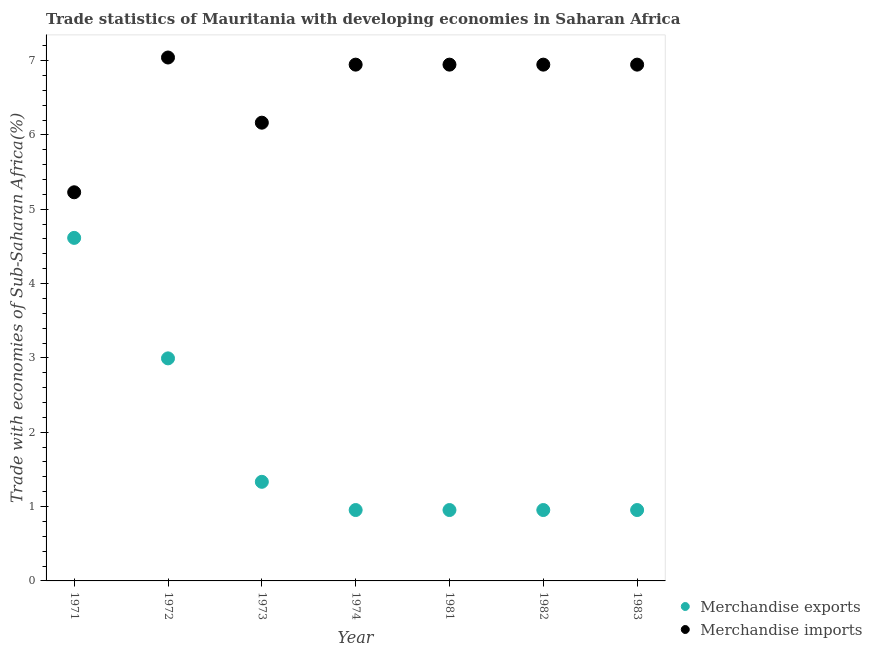Is the number of dotlines equal to the number of legend labels?
Your response must be concise. Yes. What is the merchandise imports in 1971?
Provide a short and direct response. 5.23. Across all years, what is the maximum merchandise imports?
Keep it short and to the point. 7.04. Across all years, what is the minimum merchandise exports?
Make the answer very short. 0.95. In which year was the merchandise exports maximum?
Give a very brief answer. 1971. In which year was the merchandise exports minimum?
Your answer should be very brief. 1981. What is the total merchandise imports in the graph?
Give a very brief answer. 46.21. What is the difference between the merchandise exports in 1972 and that in 1974?
Keep it short and to the point. 2.04. What is the difference between the merchandise exports in 1981 and the merchandise imports in 1973?
Offer a very short reply. -5.21. What is the average merchandise exports per year?
Your answer should be very brief. 1.82. In the year 1973, what is the difference between the merchandise exports and merchandise imports?
Your answer should be compact. -4.83. In how many years, is the merchandise imports greater than 2 %?
Your response must be concise. 7. What is the ratio of the merchandise imports in 1982 to that in 1983?
Keep it short and to the point. 1. Is the difference between the merchandise imports in 1974 and 1982 greater than the difference between the merchandise exports in 1974 and 1982?
Offer a terse response. Yes. What is the difference between the highest and the second highest merchandise imports?
Your response must be concise. 0.1. What is the difference between the highest and the lowest merchandise imports?
Your response must be concise. 1.81. In how many years, is the merchandise imports greater than the average merchandise imports taken over all years?
Offer a terse response. 5. Does the merchandise exports monotonically increase over the years?
Keep it short and to the point. No. How many dotlines are there?
Your answer should be very brief. 2. How many years are there in the graph?
Give a very brief answer. 7. Are the values on the major ticks of Y-axis written in scientific E-notation?
Offer a terse response. No. What is the title of the graph?
Offer a terse response. Trade statistics of Mauritania with developing economies in Saharan Africa. What is the label or title of the Y-axis?
Offer a very short reply. Trade with economies of Sub-Saharan Africa(%). What is the Trade with economies of Sub-Saharan Africa(%) of Merchandise exports in 1971?
Your answer should be compact. 4.61. What is the Trade with economies of Sub-Saharan Africa(%) in Merchandise imports in 1971?
Your response must be concise. 5.23. What is the Trade with economies of Sub-Saharan Africa(%) in Merchandise exports in 1972?
Make the answer very short. 2.99. What is the Trade with economies of Sub-Saharan Africa(%) in Merchandise imports in 1972?
Give a very brief answer. 7.04. What is the Trade with economies of Sub-Saharan Africa(%) in Merchandise exports in 1973?
Offer a terse response. 1.33. What is the Trade with economies of Sub-Saharan Africa(%) of Merchandise imports in 1973?
Your answer should be very brief. 6.16. What is the Trade with economies of Sub-Saharan Africa(%) in Merchandise exports in 1974?
Ensure brevity in your answer.  0.95. What is the Trade with economies of Sub-Saharan Africa(%) in Merchandise imports in 1974?
Offer a terse response. 6.94. What is the Trade with economies of Sub-Saharan Africa(%) of Merchandise exports in 1981?
Offer a terse response. 0.95. What is the Trade with economies of Sub-Saharan Africa(%) of Merchandise imports in 1981?
Keep it short and to the point. 6.94. What is the Trade with economies of Sub-Saharan Africa(%) of Merchandise exports in 1982?
Ensure brevity in your answer.  0.95. What is the Trade with economies of Sub-Saharan Africa(%) in Merchandise imports in 1982?
Provide a short and direct response. 6.94. What is the Trade with economies of Sub-Saharan Africa(%) of Merchandise exports in 1983?
Offer a terse response. 0.95. What is the Trade with economies of Sub-Saharan Africa(%) of Merchandise imports in 1983?
Provide a succinct answer. 6.94. Across all years, what is the maximum Trade with economies of Sub-Saharan Africa(%) of Merchandise exports?
Give a very brief answer. 4.61. Across all years, what is the maximum Trade with economies of Sub-Saharan Africa(%) in Merchandise imports?
Provide a succinct answer. 7.04. Across all years, what is the minimum Trade with economies of Sub-Saharan Africa(%) of Merchandise exports?
Offer a very short reply. 0.95. Across all years, what is the minimum Trade with economies of Sub-Saharan Africa(%) in Merchandise imports?
Give a very brief answer. 5.23. What is the total Trade with economies of Sub-Saharan Africa(%) in Merchandise exports in the graph?
Your response must be concise. 12.76. What is the total Trade with economies of Sub-Saharan Africa(%) in Merchandise imports in the graph?
Make the answer very short. 46.21. What is the difference between the Trade with economies of Sub-Saharan Africa(%) in Merchandise exports in 1971 and that in 1972?
Ensure brevity in your answer.  1.62. What is the difference between the Trade with economies of Sub-Saharan Africa(%) of Merchandise imports in 1971 and that in 1972?
Provide a succinct answer. -1.81. What is the difference between the Trade with economies of Sub-Saharan Africa(%) in Merchandise exports in 1971 and that in 1973?
Your answer should be compact. 3.28. What is the difference between the Trade with economies of Sub-Saharan Africa(%) in Merchandise imports in 1971 and that in 1973?
Your answer should be very brief. -0.94. What is the difference between the Trade with economies of Sub-Saharan Africa(%) of Merchandise exports in 1971 and that in 1974?
Give a very brief answer. 3.66. What is the difference between the Trade with economies of Sub-Saharan Africa(%) of Merchandise imports in 1971 and that in 1974?
Provide a succinct answer. -1.72. What is the difference between the Trade with economies of Sub-Saharan Africa(%) of Merchandise exports in 1971 and that in 1981?
Give a very brief answer. 3.66. What is the difference between the Trade with economies of Sub-Saharan Africa(%) in Merchandise imports in 1971 and that in 1981?
Ensure brevity in your answer.  -1.72. What is the difference between the Trade with economies of Sub-Saharan Africa(%) in Merchandise exports in 1971 and that in 1982?
Provide a short and direct response. 3.66. What is the difference between the Trade with economies of Sub-Saharan Africa(%) in Merchandise imports in 1971 and that in 1982?
Provide a succinct answer. -1.72. What is the difference between the Trade with economies of Sub-Saharan Africa(%) of Merchandise exports in 1971 and that in 1983?
Give a very brief answer. 3.66. What is the difference between the Trade with economies of Sub-Saharan Africa(%) of Merchandise imports in 1971 and that in 1983?
Your answer should be compact. -1.72. What is the difference between the Trade with economies of Sub-Saharan Africa(%) in Merchandise exports in 1972 and that in 1973?
Your answer should be very brief. 1.66. What is the difference between the Trade with economies of Sub-Saharan Africa(%) in Merchandise imports in 1972 and that in 1973?
Make the answer very short. 0.88. What is the difference between the Trade with economies of Sub-Saharan Africa(%) in Merchandise exports in 1972 and that in 1974?
Ensure brevity in your answer.  2.04. What is the difference between the Trade with economies of Sub-Saharan Africa(%) in Merchandise imports in 1972 and that in 1974?
Provide a succinct answer. 0.1. What is the difference between the Trade with economies of Sub-Saharan Africa(%) in Merchandise exports in 1972 and that in 1981?
Your answer should be compact. 2.04. What is the difference between the Trade with economies of Sub-Saharan Africa(%) in Merchandise imports in 1972 and that in 1981?
Keep it short and to the point. 0.1. What is the difference between the Trade with economies of Sub-Saharan Africa(%) in Merchandise exports in 1972 and that in 1982?
Make the answer very short. 2.04. What is the difference between the Trade with economies of Sub-Saharan Africa(%) of Merchandise imports in 1972 and that in 1982?
Provide a short and direct response. 0.1. What is the difference between the Trade with economies of Sub-Saharan Africa(%) of Merchandise exports in 1972 and that in 1983?
Your response must be concise. 2.04. What is the difference between the Trade with economies of Sub-Saharan Africa(%) of Merchandise imports in 1972 and that in 1983?
Provide a succinct answer. 0.1. What is the difference between the Trade with economies of Sub-Saharan Africa(%) of Merchandise exports in 1973 and that in 1974?
Offer a very short reply. 0.38. What is the difference between the Trade with economies of Sub-Saharan Africa(%) of Merchandise imports in 1973 and that in 1974?
Offer a terse response. -0.78. What is the difference between the Trade with economies of Sub-Saharan Africa(%) of Merchandise exports in 1973 and that in 1981?
Your answer should be compact. 0.38. What is the difference between the Trade with economies of Sub-Saharan Africa(%) in Merchandise imports in 1973 and that in 1981?
Provide a short and direct response. -0.78. What is the difference between the Trade with economies of Sub-Saharan Africa(%) of Merchandise exports in 1973 and that in 1982?
Offer a terse response. 0.38. What is the difference between the Trade with economies of Sub-Saharan Africa(%) of Merchandise imports in 1973 and that in 1982?
Offer a very short reply. -0.78. What is the difference between the Trade with economies of Sub-Saharan Africa(%) of Merchandise exports in 1973 and that in 1983?
Keep it short and to the point. 0.38. What is the difference between the Trade with economies of Sub-Saharan Africa(%) in Merchandise imports in 1973 and that in 1983?
Provide a succinct answer. -0.78. What is the difference between the Trade with economies of Sub-Saharan Africa(%) of Merchandise imports in 1974 and that in 1981?
Provide a short and direct response. -0. What is the difference between the Trade with economies of Sub-Saharan Africa(%) in Merchandise exports in 1974 and that in 1982?
Provide a short and direct response. -0. What is the difference between the Trade with economies of Sub-Saharan Africa(%) in Merchandise exports in 1974 and that in 1983?
Your response must be concise. -0. What is the difference between the Trade with economies of Sub-Saharan Africa(%) of Merchandise imports in 1974 and that in 1983?
Your answer should be very brief. -0. What is the difference between the Trade with economies of Sub-Saharan Africa(%) of Merchandise exports in 1981 and that in 1983?
Give a very brief answer. -0. What is the difference between the Trade with economies of Sub-Saharan Africa(%) in Merchandise imports in 1982 and that in 1983?
Make the answer very short. -0. What is the difference between the Trade with economies of Sub-Saharan Africa(%) in Merchandise exports in 1971 and the Trade with economies of Sub-Saharan Africa(%) in Merchandise imports in 1972?
Your response must be concise. -2.43. What is the difference between the Trade with economies of Sub-Saharan Africa(%) in Merchandise exports in 1971 and the Trade with economies of Sub-Saharan Africa(%) in Merchandise imports in 1973?
Keep it short and to the point. -1.55. What is the difference between the Trade with economies of Sub-Saharan Africa(%) in Merchandise exports in 1971 and the Trade with economies of Sub-Saharan Africa(%) in Merchandise imports in 1974?
Your response must be concise. -2.33. What is the difference between the Trade with economies of Sub-Saharan Africa(%) in Merchandise exports in 1971 and the Trade with economies of Sub-Saharan Africa(%) in Merchandise imports in 1981?
Offer a very short reply. -2.33. What is the difference between the Trade with economies of Sub-Saharan Africa(%) of Merchandise exports in 1971 and the Trade with economies of Sub-Saharan Africa(%) of Merchandise imports in 1982?
Ensure brevity in your answer.  -2.33. What is the difference between the Trade with economies of Sub-Saharan Africa(%) of Merchandise exports in 1971 and the Trade with economies of Sub-Saharan Africa(%) of Merchandise imports in 1983?
Give a very brief answer. -2.33. What is the difference between the Trade with economies of Sub-Saharan Africa(%) of Merchandise exports in 1972 and the Trade with economies of Sub-Saharan Africa(%) of Merchandise imports in 1973?
Ensure brevity in your answer.  -3.17. What is the difference between the Trade with economies of Sub-Saharan Africa(%) in Merchandise exports in 1972 and the Trade with economies of Sub-Saharan Africa(%) in Merchandise imports in 1974?
Give a very brief answer. -3.95. What is the difference between the Trade with economies of Sub-Saharan Africa(%) of Merchandise exports in 1972 and the Trade with economies of Sub-Saharan Africa(%) of Merchandise imports in 1981?
Give a very brief answer. -3.95. What is the difference between the Trade with economies of Sub-Saharan Africa(%) in Merchandise exports in 1972 and the Trade with economies of Sub-Saharan Africa(%) in Merchandise imports in 1982?
Provide a short and direct response. -3.95. What is the difference between the Trade with economies of Sub-Saharan Africa(%) of Merchandise exports in 1972 and the Trade with economies of Sub-Saharan Africa(%) of Merchandise imports in 1983?
Provide a short and direct response. -3.95. What is the difference between the Trade with economies of Sub-Saharan Africa(%) of Merchandise exports in 1973 and the Trade with economies of Sub-Saharan Africa(%) of Merchandise imports in 1974?
Your answer should be very brief. -5.61. What is the difference between the Trade with economies of Sub-Saharan Africa(%) in Merchandise exports in 1973 and the Trade with economies of Sub-Saharan Africa(%) in Merchandise imports in 1981?
Provide a short and direct response. -5.61. What is the difference between the Trade with economies of Sub-Saharan Africa(%) in Merchandise exports in 1973 and the Trade with economies of Sub-Saharan Africa(%) in Merchandise imports in 1982?
Offer a very short reply. -5.61. What is the difference between the Trade with economies of Sub-Saharan Africa(%) of Merchandise exports in 1973 and the Trade with economies of Sub-Saharan Africa(%) of Merchandise imports in 1983?
Give a very brief answer. -5.61. What is the difference between the Trade with economies of Sub-Saharan Africa(%) of Merchandise exports in 1974 and the Trade with economies of Sub-Saharan Africa(%) of Merchandise imports in 1981?
Your answer should be compact. -5.99. What is the difference between the Trade with economies of Sub-Saharan Africa(%) in Merchandise exports in 1974 and the Trade with economies of Sub-Saharan Africa(%) in Merchandise imports in 1982?
Your answer should be very brief. -5.99. What is the difference between the Trade with economies of Sub-Saharan Africa(%) in Merchandise exports in 1974 and the Trade with economies of Sub-Saharan Africa(%) in Merchandise imports in 1983?
Offer a terse response. -5.99. What is the difference between the Trade with economies of Sub-Saharan Africa(%) in Merchandise exports in 1981 and the Trade with economies of Sub-Saharan Africa(%) in Merchandise imports in 1982?
Offer a terse response. -5.99. What is the difference between the Trade with economies of Sub-Saharan Africa(%) of Merchandise exports in 1981 and the Trade with economies of Sub-Saharan Africa(%) of Merchandise imports in 1983?
Your response must be concise. -5.99. What is the difference between the Trade with economies of Sub-Saharan Africa(%) of Merchandise exports in 1982 and the Trade with economies of Sub-Saharan Africa(%) of Merchandise imports in 1983?
Your response must be concise. -5.99. What is the average Trade with economies of Sub-Saharan Africa(%) of Merchandise exports per year?
Your answer should be very brief. 1.82. What is the average Trade with economies of Sub-Saharan Africa(%) of Merchandise imports per year?
Your answer should be very brief. 6.6. In the year 1971, what is the difference between the Trade with economies of Sub-Saharan Africa(%) of Merchandise exports and Trade with economies of Sub-Saharan Africa(%) of Merchandise imports?
Give a very brief answer. -0.61. In the year 1972, what is the difference between the Trade with economies of Sub-Saharan Africa(%) of Merchandise exports and Trade with economies of Sub-Saharan Africa(%) of Merchandise imports?
Offer a terse response. -4.05. In the year 1973, what is the difference between the Trade with economies of Sub-Saharan Africa(%) in Merchandise exports and Trade with economies of Sub-Saharan Africa(%) in Merchandise imports?
Keep it short and to the point. -4.83. In the year 1974, what is the difference between the Trade with economies of Sub-Saharan Africa(%) in Merchandise exports and Trade with economies of Sub-Saharan Africa(%) in Merchandise imports?
Make the answer very short. -5.99. In the year 1981, what is the difference between the Trade with economies of Sub-Saharan Africa(%) in Merchandise exports and Trade with economies of Sub-Saharan Africa(%) in Merchandise imports?
Offer a very short reply. -5.99. In the year 1982, what is the difference between the Trade with economies of Sub-Saharan Africa(%) of Merchandise exports and Trade with economies of Sub-Saharan Africa(%) of Merchandise imports?
Keep it short and to the point. -5.99. In the year 1983, what is the difference between the Trade with economies of Sub-Saharan Africa(%) of Merchandise exports and Trade with economies of Sub-Saharan Africa(%) of Merchandise imports?
Offer a very short reply. -5.99. What is the ratio of the Trade with economies of Sub-Saharan Africa(%) of Merchandise exports in 1971 to that in 1972?
Offer a very short reply. 1.54. What is the ratio of the Trade with economies of Sub-Saharan Africa(%) of Merchandise imports in 1971 to that in 1972?
Your answer should be very brief. 0.74. What is the ratio of the Trade with economies of Sub-Saharan Africa(%) in Merchandise exports in 1971 to that in 1973?
Make the answer very short. 3.46. What is the ratio of the Trade with economies of Sub-Saharan Africa(%) in Merchandise imports in 1971 to that in 1973?
Your answer should be compact. 0.85. What is the ratio of the Trade with economies of Sub-Saharan Africa(%) in Merchandise exports in 1971 to that in 1974?
Your answer should be very brief. 4.84. What is the ratio of the Trade with economies of Sub-Saharan Africa(%) in Merchandise imports in 1971 to that in 1974?
Offer a very short reply. 0.75. What is the ratio of the Trade with economies of Sub-Saharan Africa(%) of Merchandise exports in 1971 to that in 1981?
Ensure brevity in your answer.  4.84. What is the ratio of the Trade with economies of Sub-Saharan Africa(%) of Merchandise imports in 1971 to that in 1981?
Keep it short and to the point. 0.75. What is the ratio of the Trade with economies of Sub-Saharan Africa(%) in Merchandise exports in 1971 to that in 1982?
Keep it short and to the point. 4.84. What is the ratio of the Trade with economies of Sub-Saharan Africa(%) in Merchandise imports in 1971 to that in 1982?
Give a very brief answer. 0.75. What is the ratio of the Trade with economies of Sub-Saharan Africa(%) of Merchandise exports in 1971 to that in 1983?
Your response must be concise. 4.84. What is the ratio of the Trade with economies of Sub-Saharan Africa(%) of Merchandise imports in 1971 to that in 1983?
Your answer should be very brief. 0.75. What is the ratio of the Trade with economies of Sub-Saharan Africa(%) in Merchandise exports in 1972 to that in 1973?
Keep it short and to the point. 2.25. What is the ratio of the Trade with economies of Sub-Saharan Africa(%) of Merchandise imports in 1972 to that in 1973?
Keep it short and to the point. 1.14. What is the ratio of the Trade with economies of Sub-Saharan Africa(%) in Merchandise exports in 1972 to that in 1974?
Give a very brief answer. 3.14. What is the ratio of the Trade with economies of Sub-Saharan Africa(%) of Merchandise imports in 1972 to that in 1974?
Offer a terse response. 1.01. What is the ratio of the Trade with economies of Sub-Saharan Africa(%) of Merchandise exports in 1972 to that in 1981?
Make the answer very short. 3.14. What is the ratio of the Trade with economies of Sub-Saharan Africa(%) of Merchandise imports in 1972 to that in 1981?
Ensure brevity in your answer.  1.01. What is the ratio of the Trade with economies of Sub-Saharan Africa(%) in Merchandise exports in 1972 to that in 1982?
Your answer should be very brief. 3.14. What is the ratio of the Trade with economies of Sub-Saharan Africa(%) of Merchandise imports in 1972 to that in 1982?
Your response must be concise. 1.01. What is the ratio of the Trade with economies of Sub-Saharan Africa(%) in Merchandise exports in 1972 to that in 1983?
Ensure brevity in your answer.  3.14. What is the ratio of the Trade with economies of Sub-Saharan Africa(%) in Merchandise imports in 1972 to that in 1983?
Give a very brief answer. 1.01. What is the ratio of the Trade with economies of Sub-Saharan Africa(%) in Merchandise exports in 1973 to that in 1974?
Your answer should be very brief. 1.4. What is the ratio of the Trade with economies of Sub-Saharan Africa(%) in Merchandise imports in 1973 to that in 1974?
Keep it short and to the point. 0.89. What is the ratio of the Trade with economies of Sub-Saharan Africa(%) in Merchandise exports in 1973 to that in 1981?
Provide a short and direct response. 1.4. What is the ratio of the Trade with economies of Sub-Saharan Africa(%) in Merchandise imports in 1973 to that in 1981?
Make the answer very short. 0.89. What is the ratio of the Trade with economies of Sub-Saharan Africa(%) in Merchandise exports in 1973 to that in 1982?
Provide a succinct answer. 1.4. What is the ratio of the Trade with economies of Sub-Saharan Africa(%) of Merchandise imports in 1973 to that in 1982?
Your answer should be compact. 0.89. What is the ratio of the Trade with economies of Sub-Saharan Africa(%) of Merchandise exports in 1973 to that in 1983?
Make the answer very short. 1.4. What is the ratio of the Trade with economies of Sub-Saharan Africa(%) in Merchandise imports in 1973 to that in 1983?
Offer a terse response. 0.89. What is the ratio of the Trade with economies of Sub-Saharan Africa(%) of Merchandise exports in 1974 to that in 1981?
Give a very brief answer. 1. What is the ratio of the Trade with economies of Sub-Saharan Africa(%) in Merchandise imports in 1974 to that in 1982?
Your answer should be very brief. 1. What is the ratio of the Trade with economies of Sub-Saharan Africa(%) of Merchandise imports in 1974 to that in 1983?
Your response must be concise. 1. What is the ratio of the Trade with economies of Sub-Saharan Africa(%) of Merchandise exports in 1981 to that in 1982?
Provide a short and direct response. 1. What is the ratio of the Trade with economies of Sub-Saharan Africa(%) of Merchandise exports in 1981 to that in 1983?
Your response must be concise. 1. What is the ratio of the Trade with economies of Sub-Saharan Africa(%) of Merchandise imports in 1981 to that in 1983?
Your response must be concise. 1. What is the difference between the highest and the second highest Trade with economies of Sub-Saharan Africa(%) of Merchandise exports?
Ensure brevity in your answer.  1.62. What is the difference between the highest and the second highest Trade with economies of Sub-Saharan Africa(%) of Merchandise imports?
Provide a succinct answer. 0.1. What is the difference between the highest and the lowest Trade with economies of Sub-Saharan Africa(%) of Merchandise exports?
Provide a succinct answer. 3.66. What is the difference between the highest and the lowest Trade with economies of Sub-Saharan Africa(%) in Merchandise imports?
Your response must be concise. 1.81. 